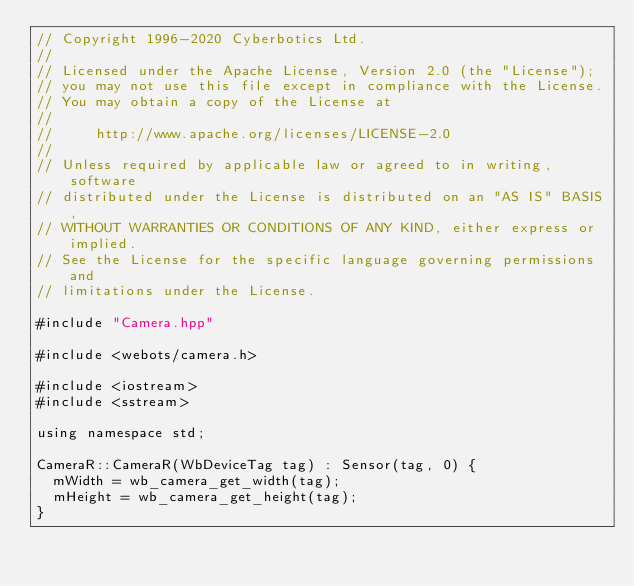Convert code to text. <code><loc_0><loc_0><loc_500><loc_500><_C++_>// Copyright 1996-2020 Cyberbotics Ltd.
//
// Licensed under the Apache License, Version 2.0 (the "License");
// you may not use this file except in compliance with the License.
// You may obtain a copy of the License at
//
//     http://www.apache.org/licenses/LICENSE-2.0
//
// Unless required by applicable law or agreed to in writing, software
// distributed under the License is distributed on an "AS IS" BASIS,
// WITHOUT WARRANTIES OR CONDITIONS OF ANY KIND, either express or implied.
// See the License for the specific language governing permissions and
// limitations under the License.

#include "Camera.hpp"

#include <webots/camera.h>

#include <iostream>
#include <sstream>

using namespace std;

CameraR::CameraR(WbDeviceTag tag) : Sensor(tag, 0) {
  mWidth = wb_camera_get_width(tag);
  mHeight = wb_camera_get_height(tag);
}
</code> 